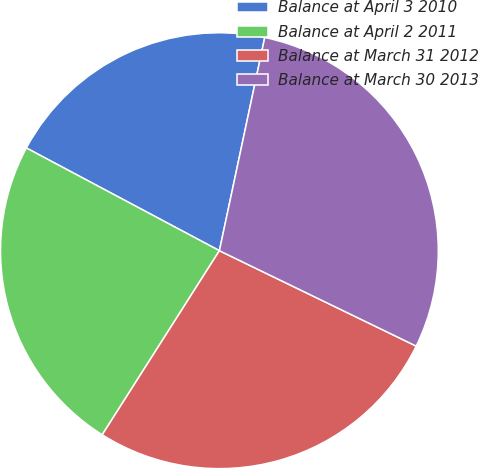<chart> <loc_0><loc_0><loc_500><loc_500><pie_chart><fcel>Balance at April 3 2010<fcel>Balance at April 2 2011<fcel>Balance at March 31 2012<fcel>Balance at March 30 2013<nl><fcel>20.51%<fcel>23.82%<fcel>26.78%<fcel>28.89%<nl></chart> 